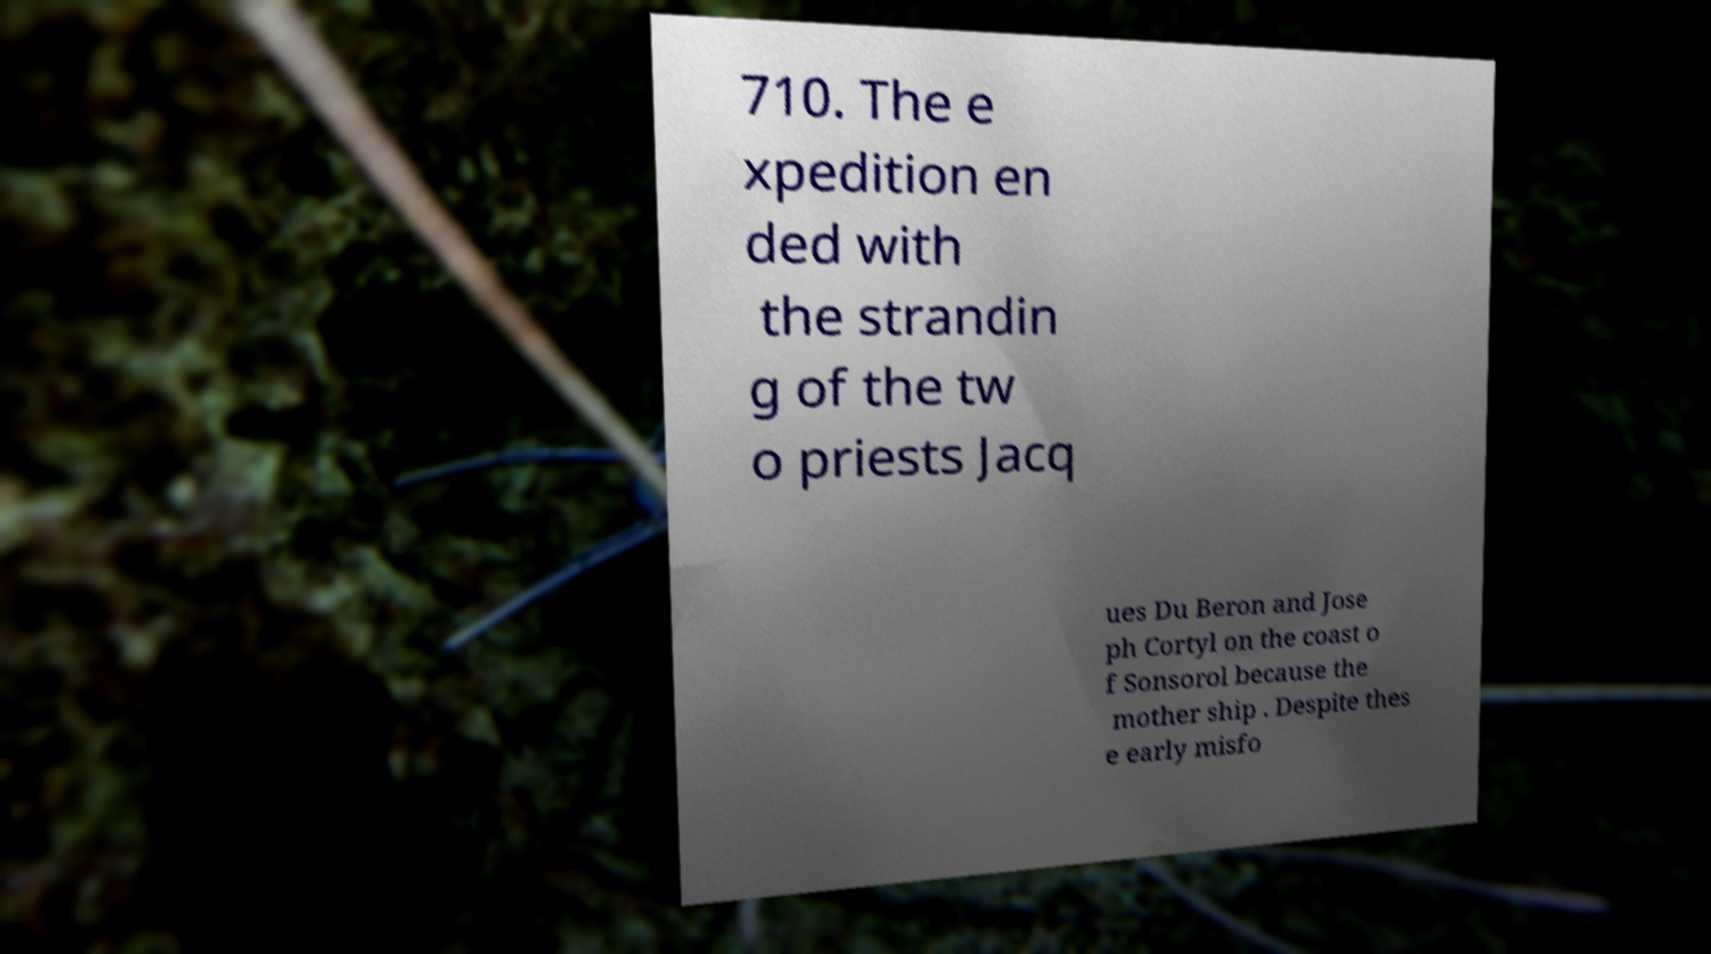Please read and relay the text visible in this image. What does it say? 710. The e xpedition en ded with the strandin g of the tw o priests Jacq ues Du Beron and Jose ph Cortyl on the coast o f Sonsorol because the mother ship . Despite thes e early misfo 